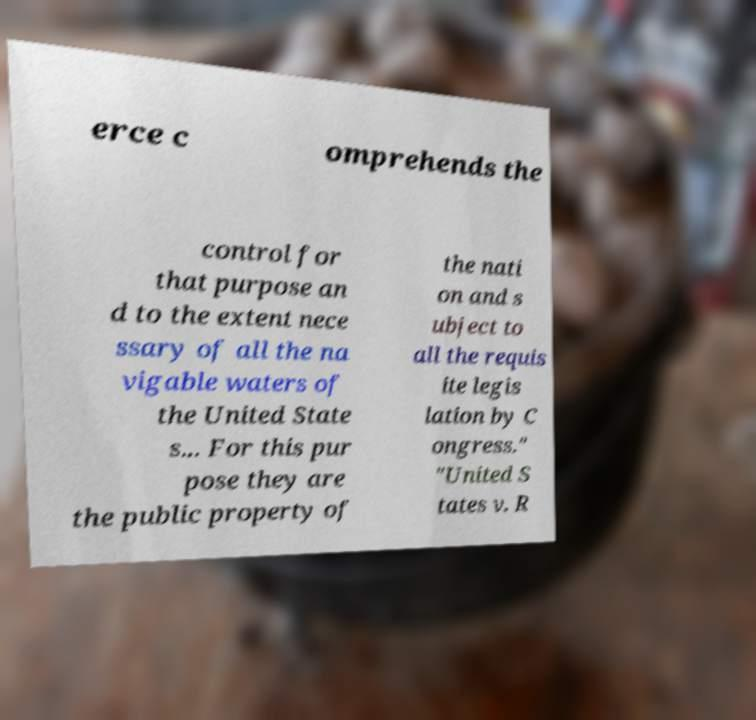I need the written content from this picture converted into text. Can you do that? erce c omprehends the control for that purpose an d to the extent nece ssary of all the na vigable waters of the United State s... For this pur pose they are the public property of the nati on and s ubject to all the requis ite legis lation by C ongress." "United S tates v. R 